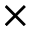<formula> <loc_0><loc_0><loc_500><loc_500>\times</formula> 